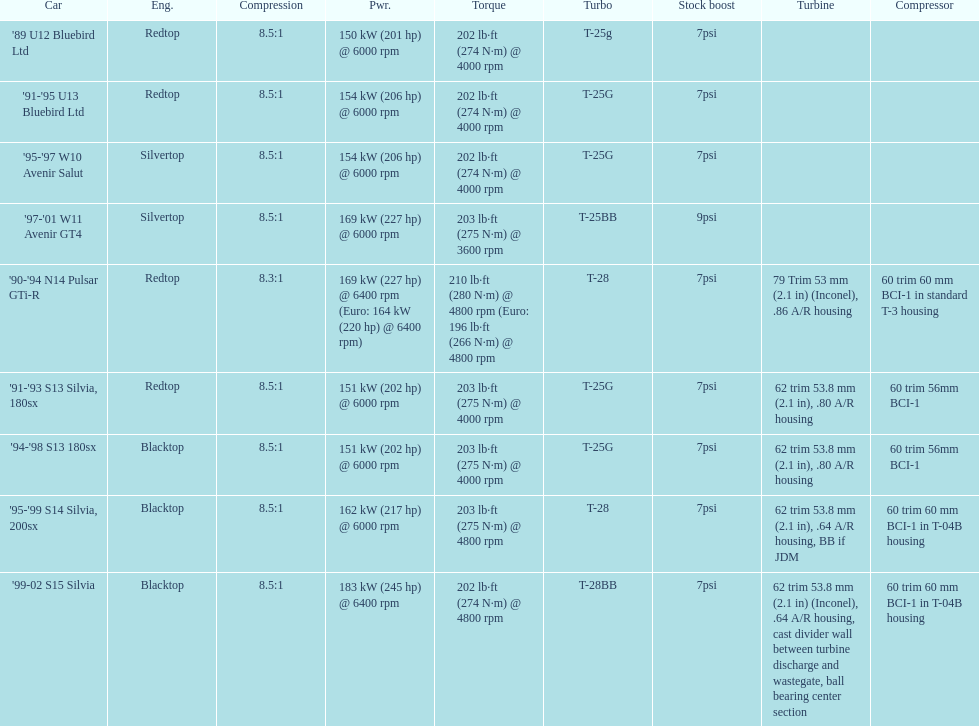Which engine(s) has the least amount of power? Redtop. 